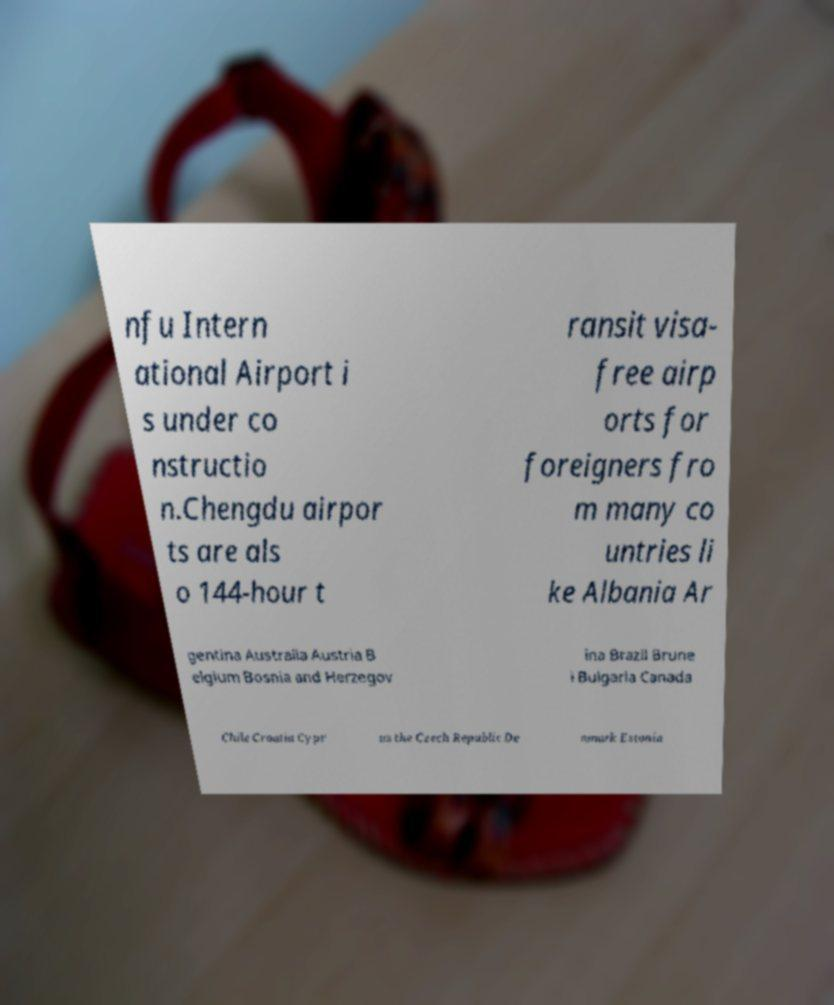There's text embedded in this image that I need extracted. Can you transcribe it verbatim? nfu Intern ational Airport i s under co nstructio n.Chengdu airpor ts are als o 144-hour t ransit visa- free airp orts for foreigners fro m many co untries li ke Albania Ar gentina Australia Austria B elgium Bosnia and Herzegov ina Brazil Brune i Bulgaria Canada Chile Croatia Cypr us the Czech Republic De nmark Estonia 